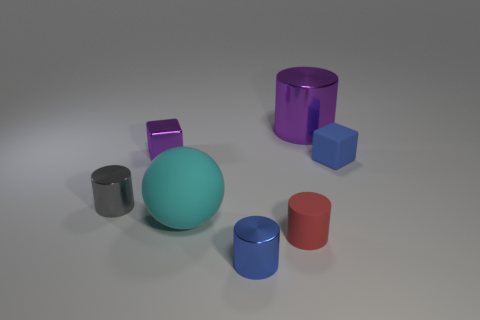What shape is the tiny blue thing that is in front of the rubber ball?
Your answer should be very brief. Cylinder. Is the shape of the gray thing the same as the red thing?
Your answer should be compact. Yes. Are there the same number of metallic cylinders that are on the right side of the purple shiny cube and purple metallic blocks?
Make the answer very short. No. The small blue rubber thing has what shape?
Provide a succinct answer. Cube. Is there anything else that has the same color as the matte ball?
Your answer should be very brief. No. Is the size of the metal cylinder to the left of the sphere the same as the rubber block that is on the right side of the cyan ball?
Your answer should be very brief. Yes. There is a blue thing behind the large cyan rubber thing that is left of the small blue metallic object; what shape is it?
Your answer should be compact. Cube. Is the size of the purple metallic cylinder the same as the blue thing that is left of the blue matte thing?
Provide a short and direct response. No. There is a purple object left of the purple thing that is on the right side of the small shiny thing behind the small blue matte block; what is its size?
Your answer should be very brief. Small. How many things are metal cylinders behind the small purple block or blue matte cylinders?
Your response must be concise. 1. 